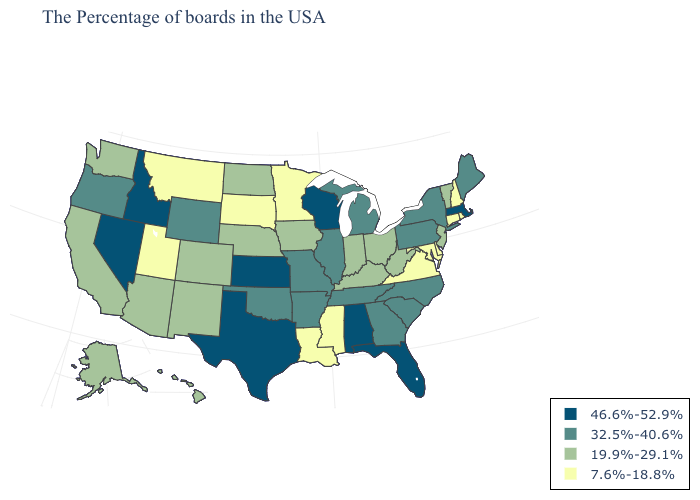Name the states that have a value in the range 19.9%-29.1%?
Keep it brief. Vermont, New Jersey, West Virginia, Ohio, Kentucky, Indiana, Iowa, Nebraska, North Dakota, Colorado, New Mexico, Arizona, California, Washington, Alaska, Hawaii. Does the first symbol in the legend represent the smallest category?
Be succinct. No. Which states have the highest value in the USA?
Concise answer only. Massachusetts, Florida, Alabama, Wisconsin, Kansas, Texas, Idaho, Nevada. What is the lowest value in states that border Wisconsin?
Short answer required. 7.6%-18.8%. Which states hav the highest value in the Northeast?
Answer briefly. Massachusetts. Which states have the lowest value in the South?
Short answer required. Delaware, Maryland, Virginia, Mississippi, Louisiana. Name the states that have a value in the range 19.9%-29.1%?
Quick response, please. Vermont, New Jersey, West Virginia, Ohio, Kentucky, Indiana, Iowa, Nebraska, North Dakota, Colorado, New Mexico, Arizona, California, Washington, Alaska, Hawaii. Name the states that have a value in the range 7.6%-18.8%?
Give a very brief answer. Rhode Island, New Hampshire, Connecticut, Delaware, Maryland, Virginia, Mississippi, Louisiana, Minnesota, South Dakota, Utah, Montana. Does Wisconsin have the highest value in the MidWest?
Be succinct. Yes. Does the first symbol in the legend represent the smallest category?
Give a very brief answer. No. Does Indiana have the highest value in the MidWest?
Write a very short answer. No. Is the legend a continuous bar?
Short answer required. No. What is the lowest value in states that border Arizona?
Give a very brief answer. 7.6%-18.8%. What is the value of Minnesota?
Keep it brief. 7.6%-18.8%. What is the value of Louisiana?
Write a very short answer. 7.6%-18.8%. 